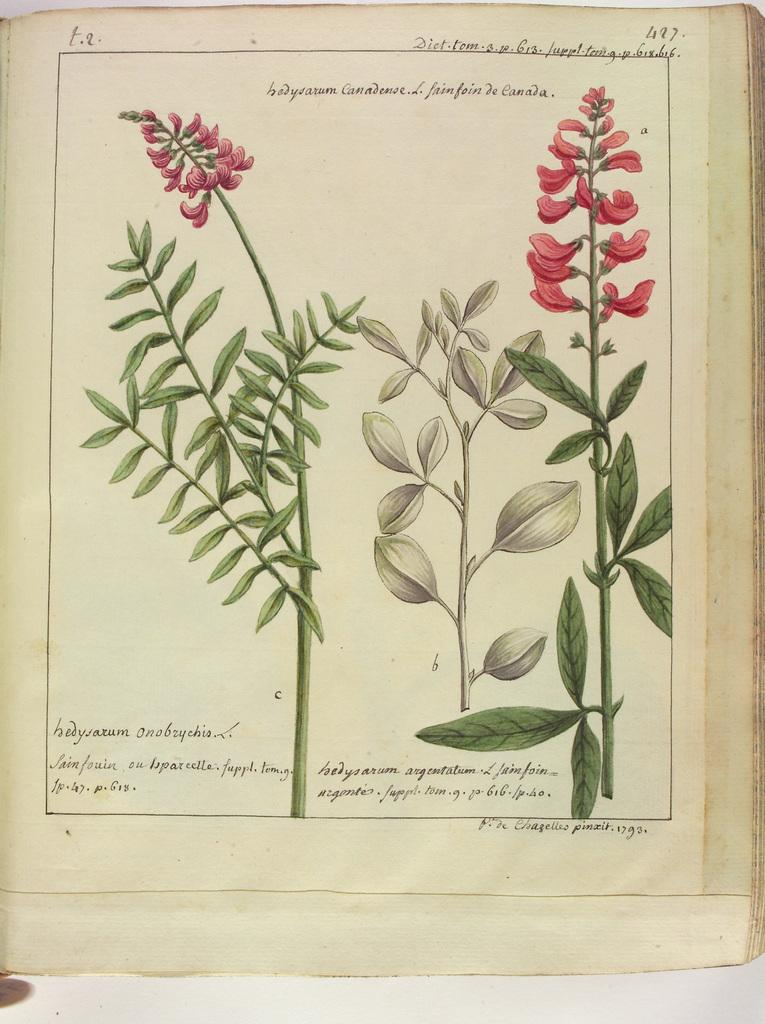What is the main subject of the image? The main subject of the image is an open book. What is depicted on the paper inside the book? There are plants depicted on the paper. What type of content is present on the paper? There is text and numbers on the paper. Can you see a ghost holding a tray with flowers in the image? No, there is no ghost, tray, or flowers present in the image. The image only features an open book with plants, text, and numbers on the paper. 